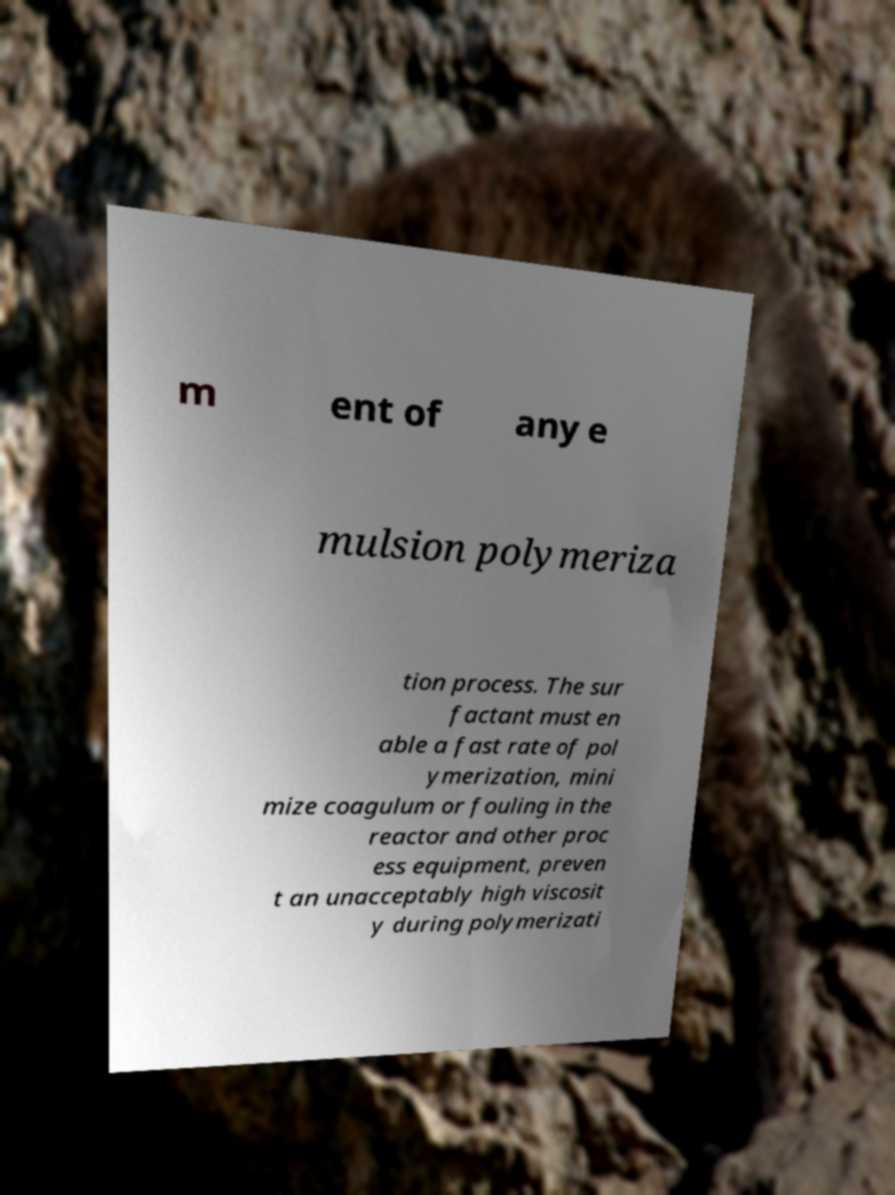There's text embedded in this image that I need extracted. Can you transcribe it verbatim? m ent of any e mulsion polymeriza tion process. The sur factant must en able a fast rate of pol ymerization, mini mize coagulum or fouling in the reactor and other proc ess equipment, preven t an unacceptably high viscosit y during polymerizati 